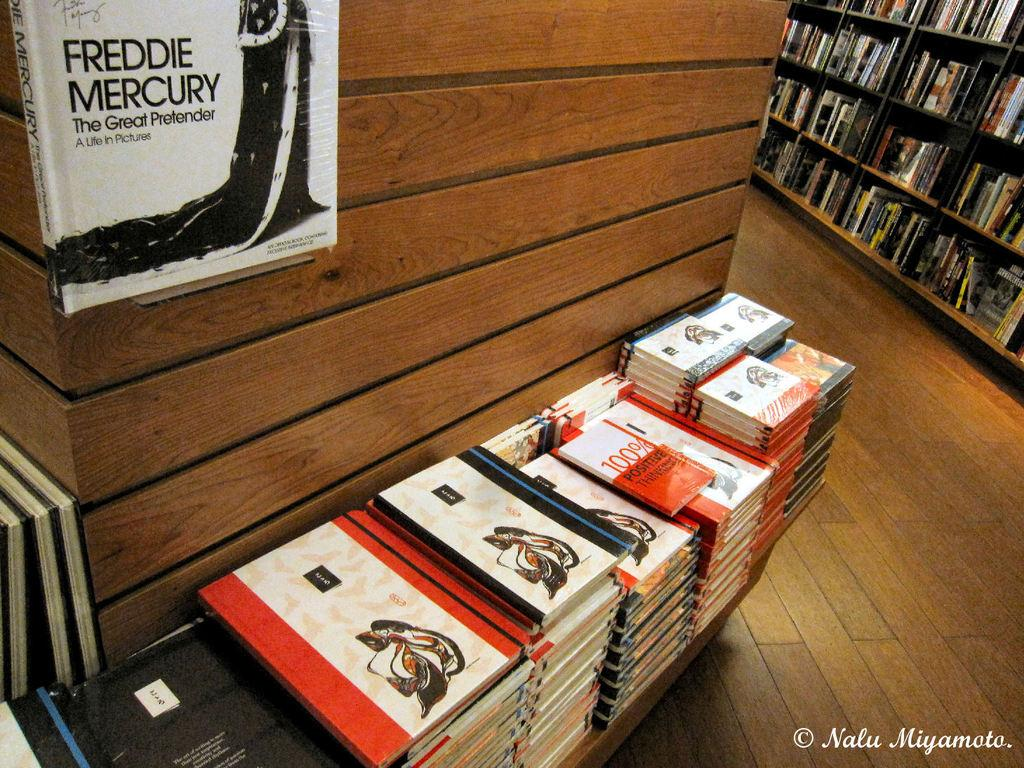Provide a one-sentence caption for the provided image. A book display in a book store with the top display book reading Freddie Mercury. 